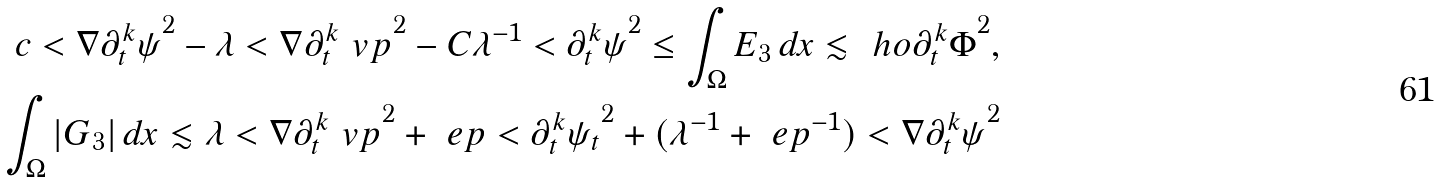<formula> <loc_0><loc_0><loc_500><loc_500>c < { \nabla \partial _ { t } ^ { k } \psi } ^ { 2 } - \lambda < { \nabla \partial _ { t } ^ { k } \ v p } ^ { 2 } - C \lambda ^ { - 1 } < { \partial _ { t } ^ { k } \psi } ^ { 2 } \leq \int _ { \Omega } E _ { 3 } \, d x \lesssim \ h o { \partial _ { t } ^ { k } \Phi } ^ { 2 } , \\ \int _ { \Omega } | G _ { 3 } | \, d x \lesssim \lambda < { \nabla \partial _ { t } ^ { k } \ v p } ^ { 2 } + \ e p < { \partial _ { t } ^ { k } \psi _ { t } } ^ { 2 } + ( \lambda ^ { - 1 } + \ e p ^ { - 1 } ) < { \nabla \partial _ { t } ^ { k } \psi } ^ { 2 }</formula> 